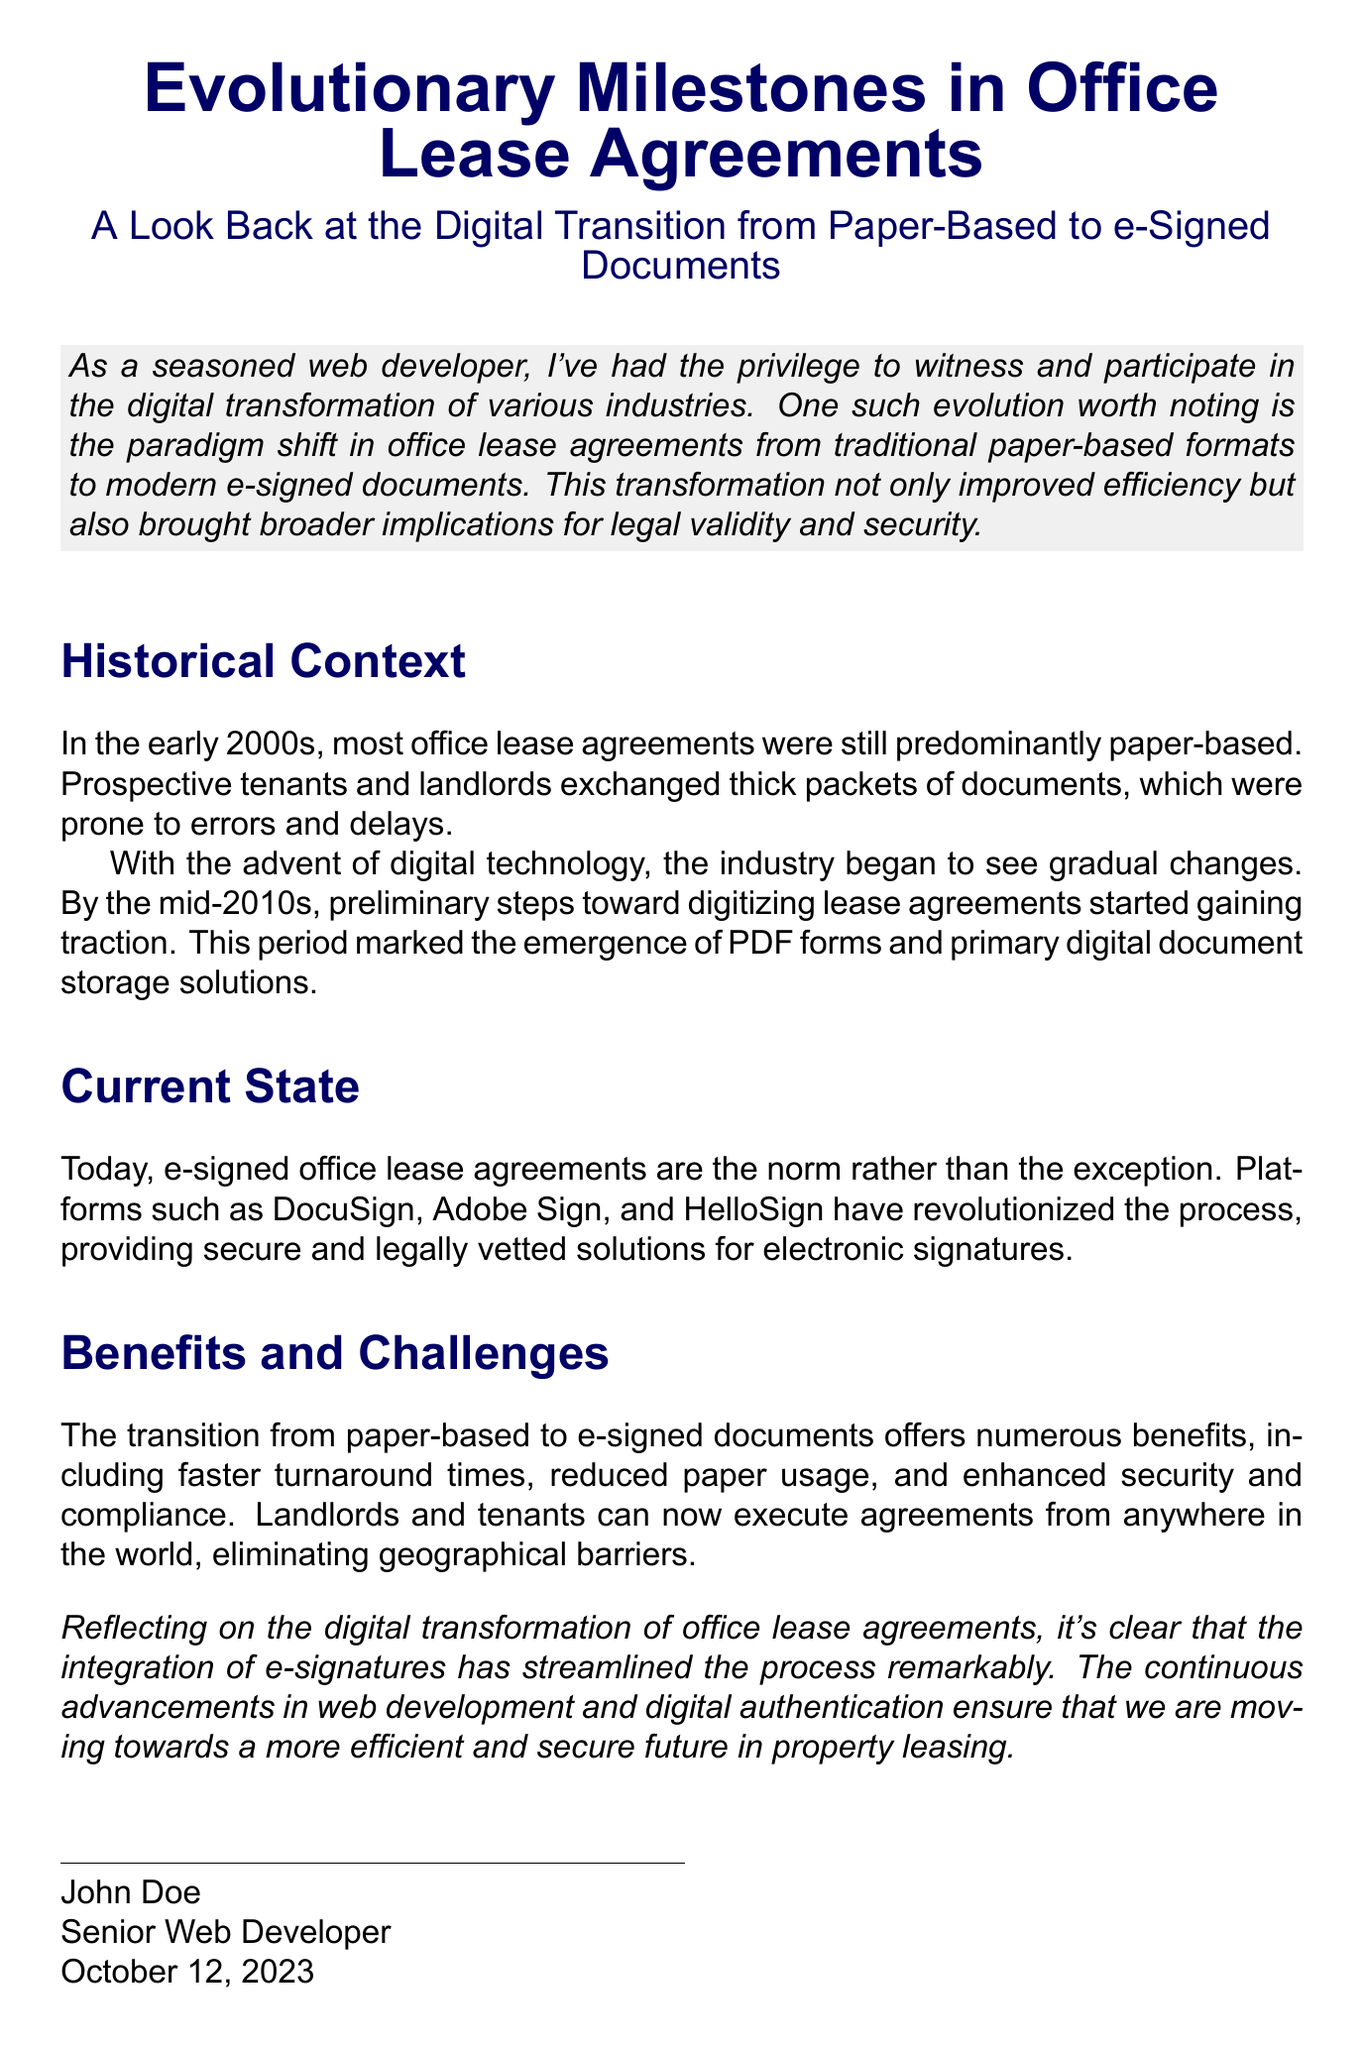What is the title of the document? The title is prominently displayed at the top of the document, indicating the main subject.
Answer: Evolutionary Milestones in Office Lease Agreements Who is the author of the document? The author's name is provided at the end of the document.
Answer: John Doe What is the date of the document? The date is also included at the end of the document, representing when it was completed.
Answer: October 12, 2023 What technology solutions are mentioned for e-signing? The document lists specific platforms that facilitate e-signing of lease agreements.
Answer: DocuSign, Adobe Sign, HelloSign In which decade did the transition from paper-based to e-signed documents begin? The document describes the historical context, pinpointing the start of the transition.
Answer: 2010s What is a key benefit of e-signed agreements mentioned? The document emphasizes significant advantages provided by e-signed agreements in its benefits section.
Answer: Faster turnaround times What significant change in the leasing process does the document reflect? The document highlights a major transformation in the execution of office lease agreements.
Answer: Integration of e-signatures What is the color of the section titles in the document? The document specifies the color used for section titles in the formatting instructions.
Answer: Dark blue 